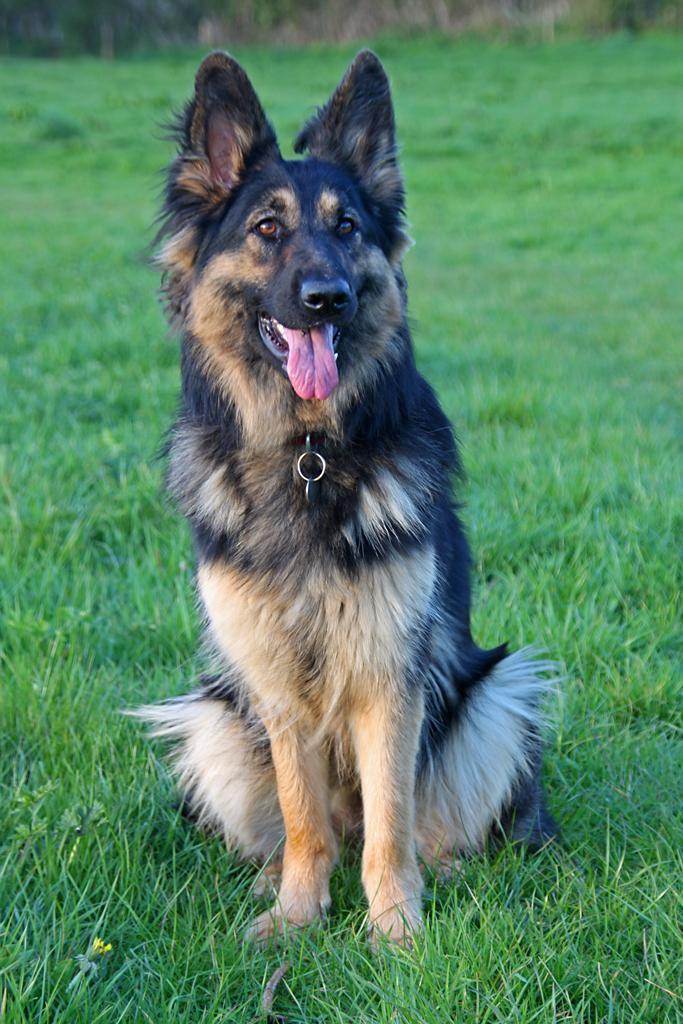Describe this image in one or two sentences. In this picture there is a dog sitting on the grass. At the back there might be trees and the dog is in black and cream color. 